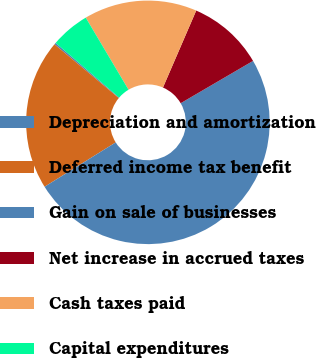<chart> <loc_0><loc_0><loc_500><loc_500><pie_chart><fcel>Depreciation and amortization<fcel>Deferred income tax benefit<fcel>Gain on sale of businesses<fcel>Net increase in accrued taxes<fcel>Cash taxes paid<fcel>Capital expenditures<nl><fcel>0.23%<fcel>19.95%<fcel>49.54%<fcel>10.09%<fcel>15.02%<fcel>5.16%<nl></chart> 